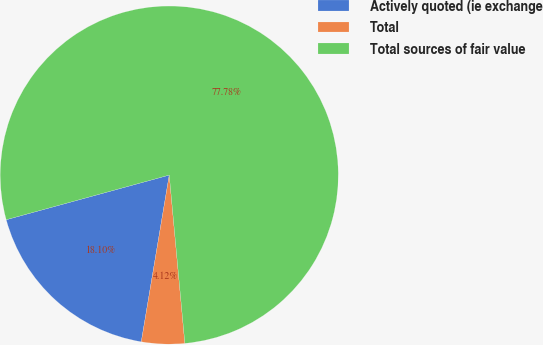Convert chart. <chart><loc_0><loc_0><loc_500><loc_500><pie_chart><fcel>Actively quoted (ie exchange<fcel>Total<fcel>Total sources of fair value<nl><fcel>18.1%<fcel>4.12%<fcel>77.79%<nl></chart> 